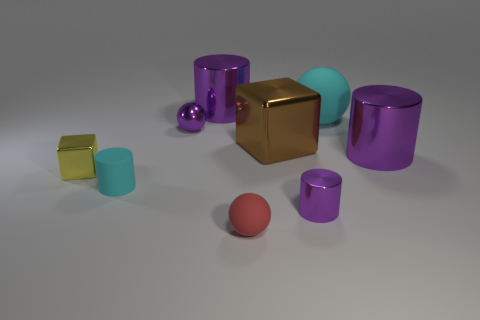Is there a big shiny thing of the same color as the tiny metallic sphere?
Your answer should be compact. Yes. There is a cylinder that is the same color as the large matte object; what size is it?
Give a very brief answer. Small. There is a small metal thing that is the same color as the small shiny cylinder; what is its shape?
Make the answer very short. Sphere. Is there anything else that has the same color as the large rubber thing?
Offer a terse response. Yes. There is a large ball; does it have the same color as the small rubber object left of the small purple shiny sphere?
Offer a terse response. Yes. How many things are either tiny rubber objects in front of the tiny purple metallic cylinder or purple shiny objects that are to the right of the tiny shiny ball?
Provide a succinct answer. 4. Are there more tiny purple shiny objects that are left of the small metal cylinder than large brown objects in front of the brown object?
Give a very brief answer. Yes. There is a ball in front of the tiny object that is to the left of the rubber cylinder in front of the yellow cube; what is it made of?
Provide a succinct answer. Rubber. There is a cyan thing that is in front of the small shiny ball; is it the same shape as the cyan thing that is behind the tiny cyan matte object?
Your answer should be very brief. No. Are there any yellow metal objects that have the same size as the red matte thing?
Ensure brevity in your answer.  Yes. 